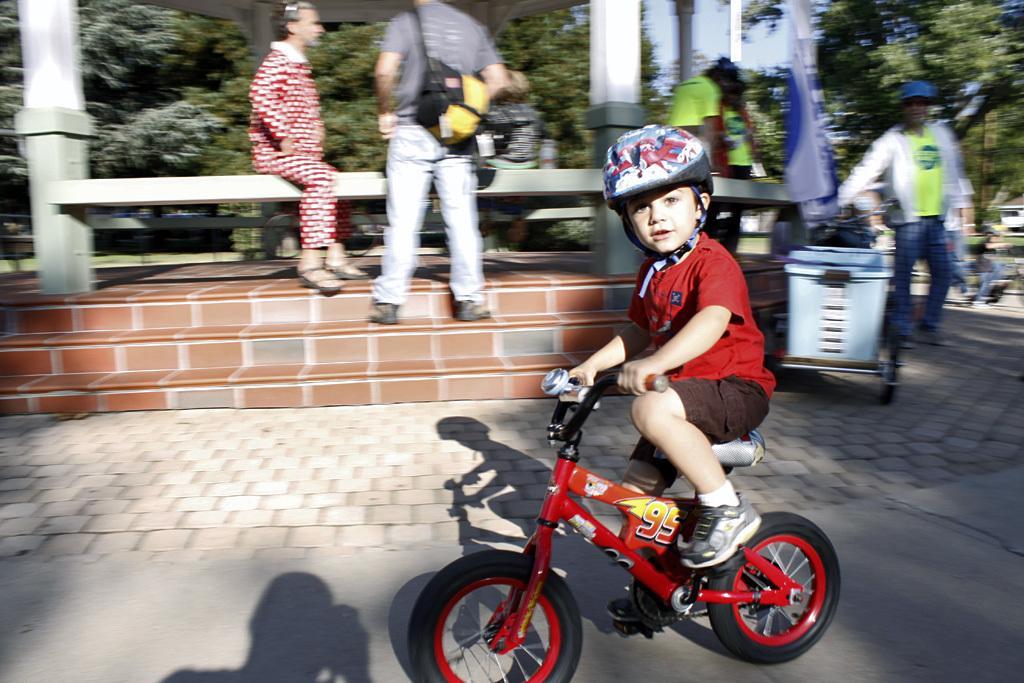In one or two sentences, can you explain what this image depicts? in this image i can see a small boy riding a red colored bicycle. he is wearing helmet and a red colored t shirt. he is riding on the road. behind him there are stairs and people are standing. a man is wearing a grey shirt ,a jeans and carrying a black and yellow bag. behind him there are many trees and a pole 